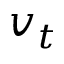Convert formula to latex. <formula><loc_0><loc_0><loc_500><loc_500>v _ { t }</formula> 